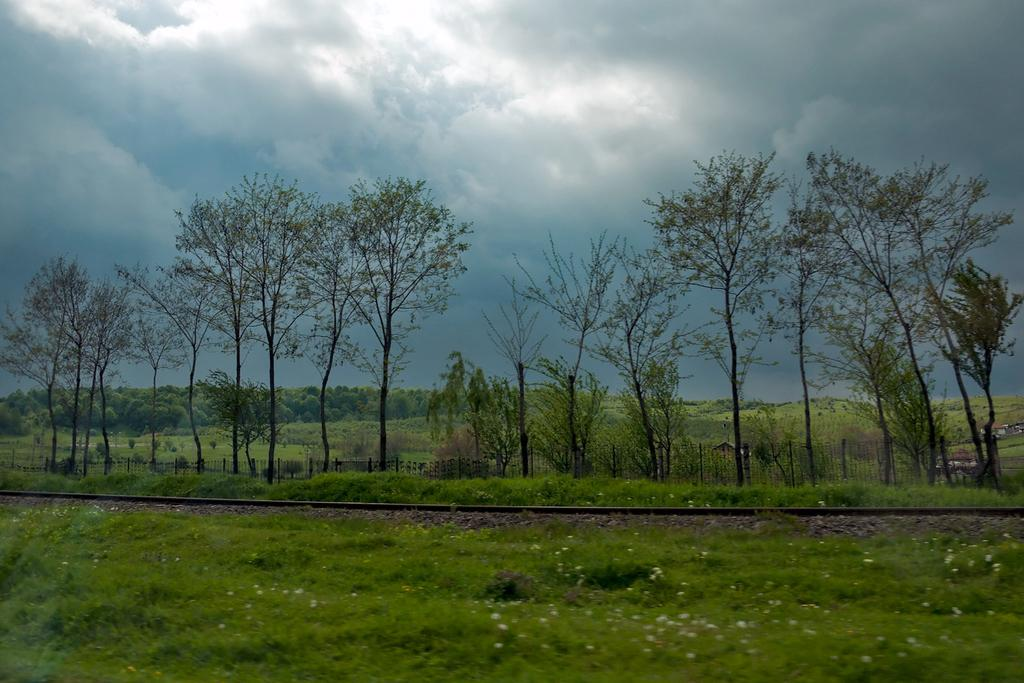What is located in the middle of the image? There is a railway track in the middle of the image. What is visible at the top of the image? The sky is visible at the top of the image. What can be seen in the background of the image? There are trees in the background of the image. What is present at the bottom of the image? There are plants at the bottom of the image. What type of flame can be seen coming from the train in the image? There is no train present in the image, so there is no flame to be seen. 